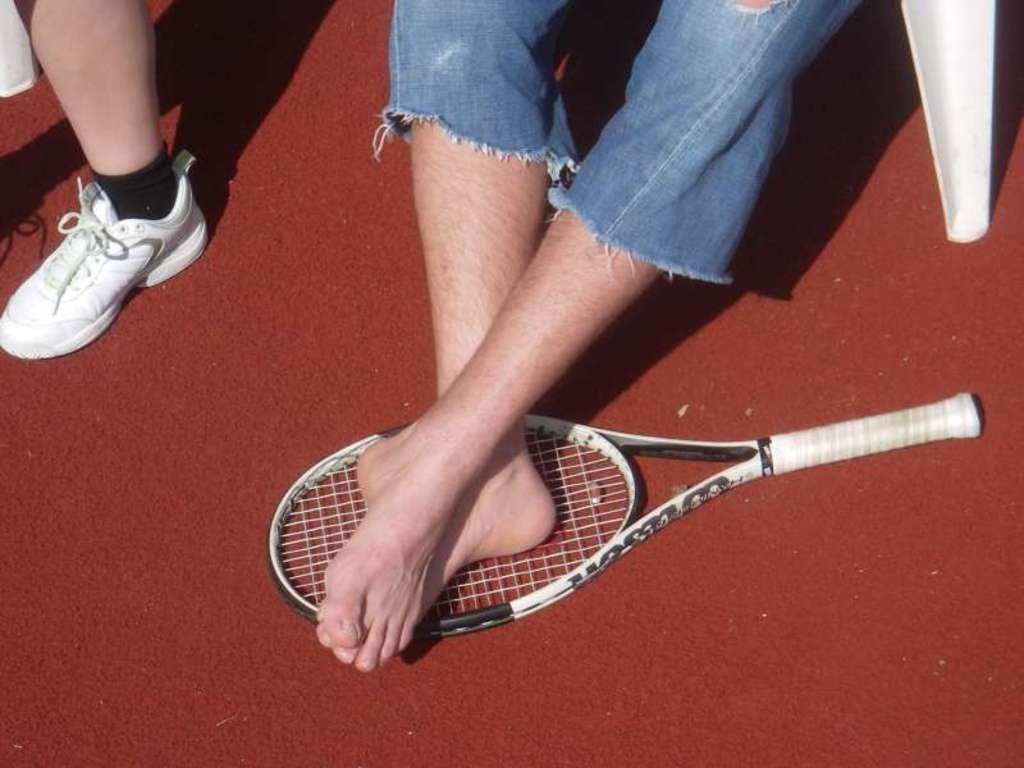Please provide a concise description of this image. In this picture I can see a bat and person's legs. Here I can see a white color shoe. 